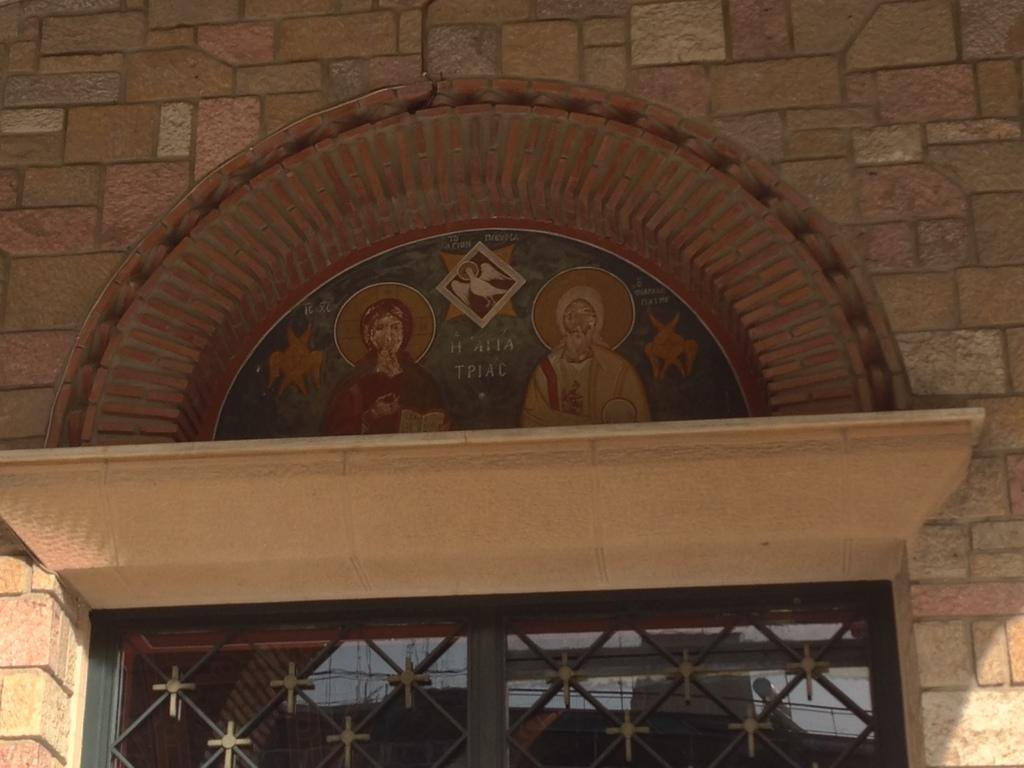What type of structure is visible in the image? There is a building in the image. What feature can be seen on the building? The building has a wall. What is present on the wall? The wall has a window and carvings. What is attached to the wall in the image? There is a board with text in the image. What else is on the board besides text? The board has images on it. What type of store is being destroyed in the image? There is no store or destruction present in the image; it features a building with a wall, window, carvings, and a board with text and images. 